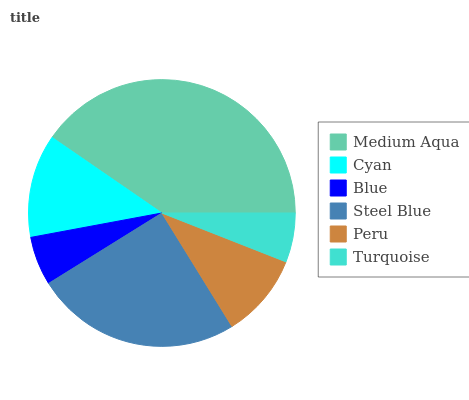Is Blue the minimum?
Answer yes or no. Yes. Is Medium Aqua the maximum?
Answer yes or no. Yes. Is Cyan the minimum?
Answer yes or no. No. Is Cyan the maximum?
Answer yes or no. No. Is Medium Aqua greater than Cyan?
Answer yes or no. Yes. Is Cyan less than Medium Aqua?
Answer yes or no. Yes. Is Cyan greater than Medium Aqua?
Answer yes or no. No. Is Medium Aqua less than Cyan?
Answer yes or no. No. Is Cyan the high median?
Answer yes or no. Yes. Is Peru the low median?
Answer yes or no. Yes. Is Steel Blue the high median?
Answer yes or no. No. Is Blue the low median?
Answer yes or no. No. 